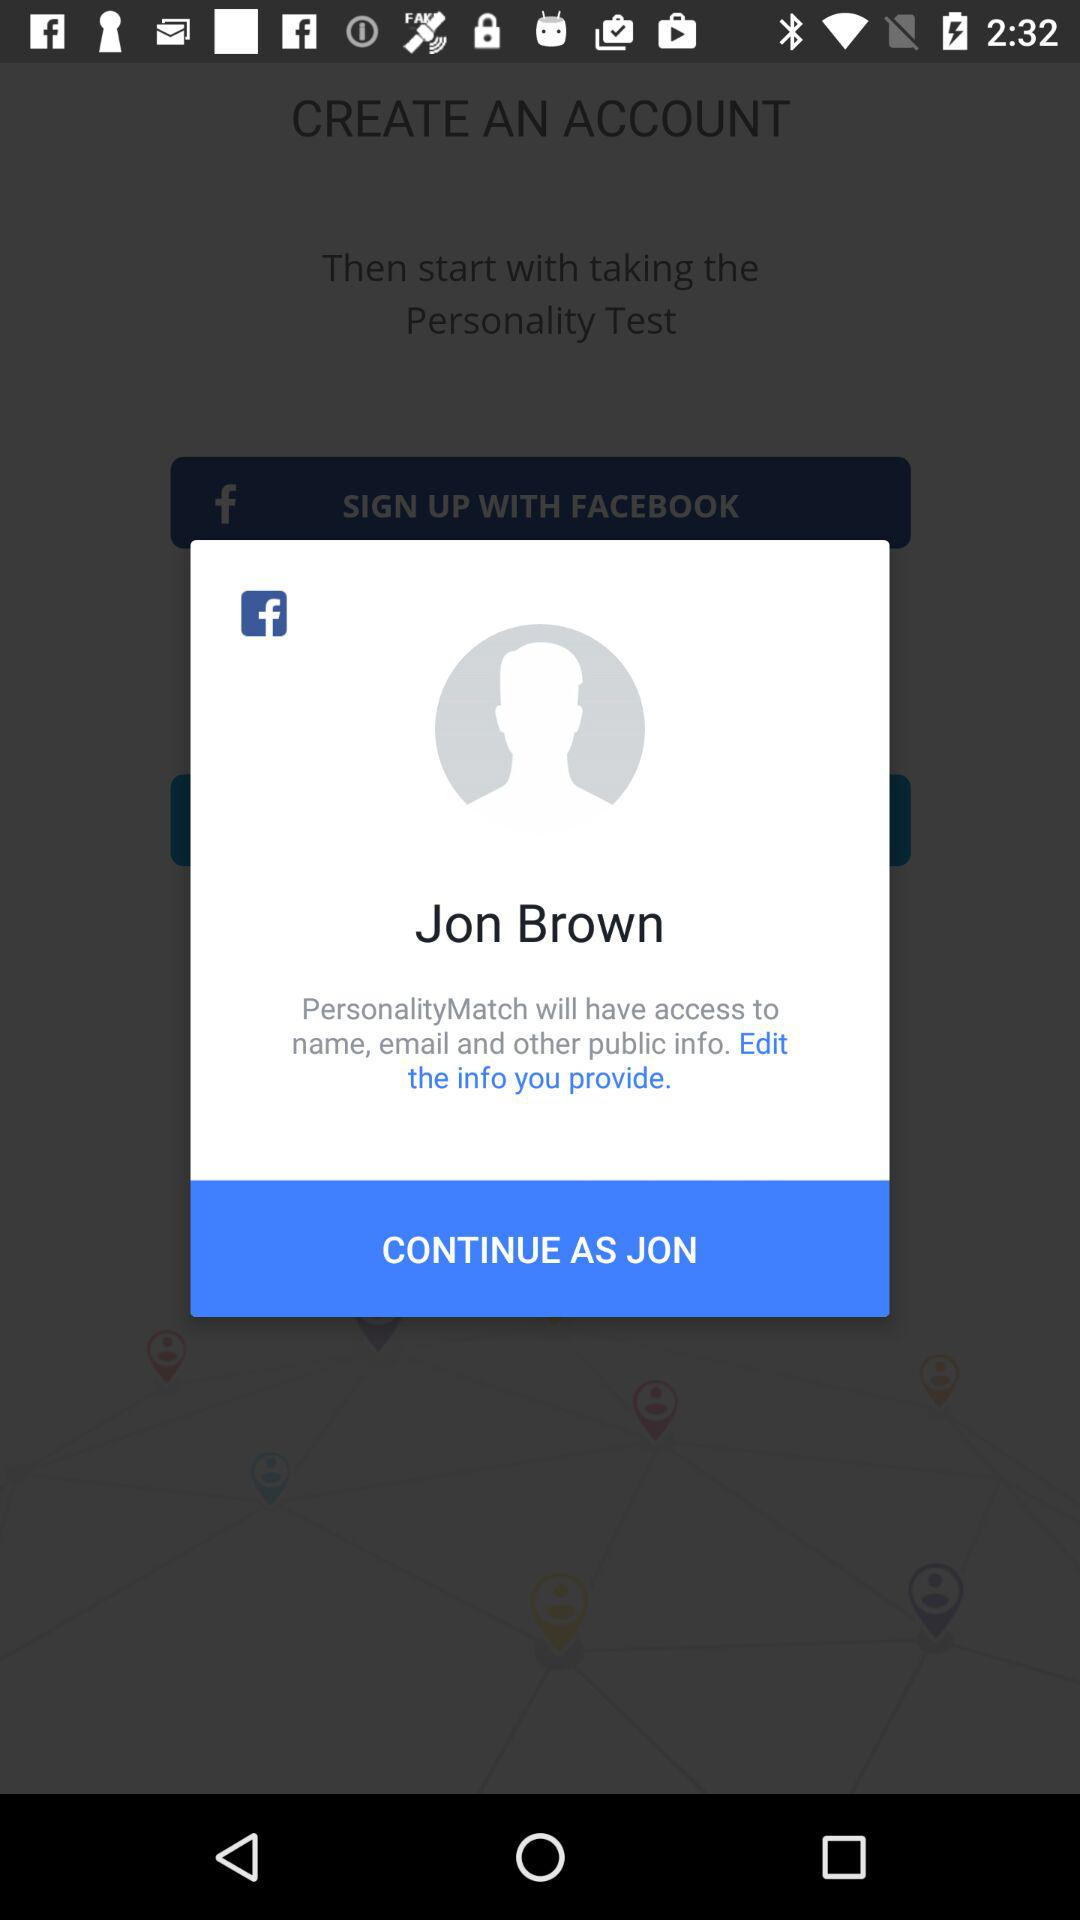How many questions are on the personality test?
When the provided information is insufficient, respond with <no answer>. <no answer> 